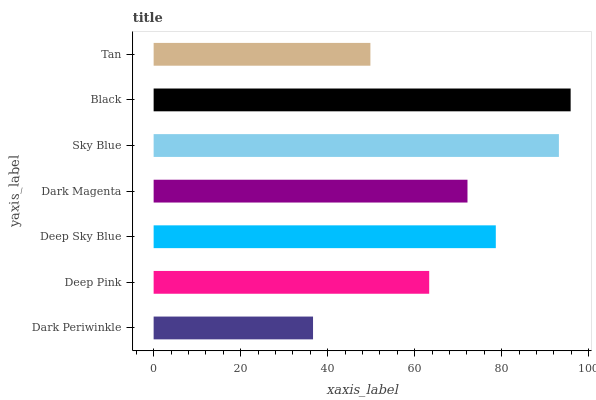Is Dark Periwinkle the minimum?
Answer yes or no. Yes. Is Black the maximum?
Answer yes or no. Yes. Is Deep Pink the minimum?
Answer yes or no. No. Is Deep Pink the maximum?
Answer yes or no. No. Is Deep Pink greater than Dark Periwinkle?
Answer yes or no. Yes. Is Dark Periwinkle less than Deep Pink?
Answer yes or no. Yes. Is Dark Periwinkle greater than Deep Pink?
Answer yes or no. No. Is Deep Pink less than Dark Periwinkle?
Answer yes or no. No. Is Dark Magenta the high median?
Answer yes or no. Yes. Is Dark Magenta the low median?
Answer yes or no. Yes. Is Deep Pink the high median?
Answer yes or no. No. Is Tan the low median?
Answer yes or no. No. 